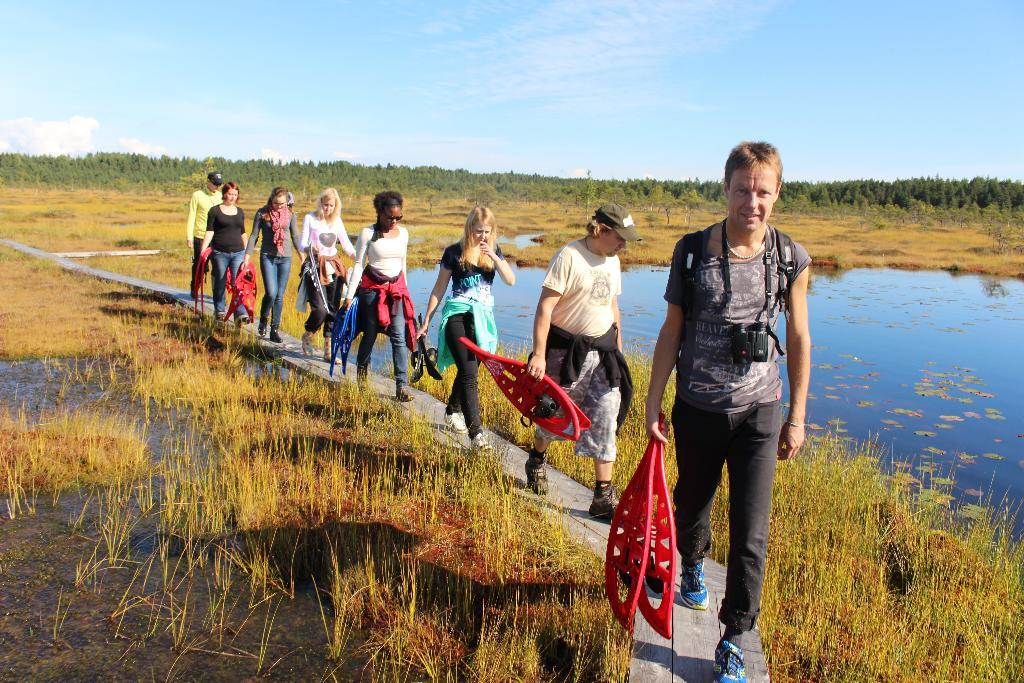What can be seen in the background of the image? The sky is visible in the background of the image. What type of natural environment is present in the image? There are trees and a field in the image, indicating a natural environment. What is the water feature in the image? There is water visible in the image. What are the people in the image doing? The people are holding objects and walking on a wooden pathway in the image. What type of carriage can be seen in the image? There is no carriage present in the image. Can you tell me how many dimes are scattered on the wooden pathway? There are no dimes visible in the image; the people are holding objects, but the nature of those objects is not specified. 